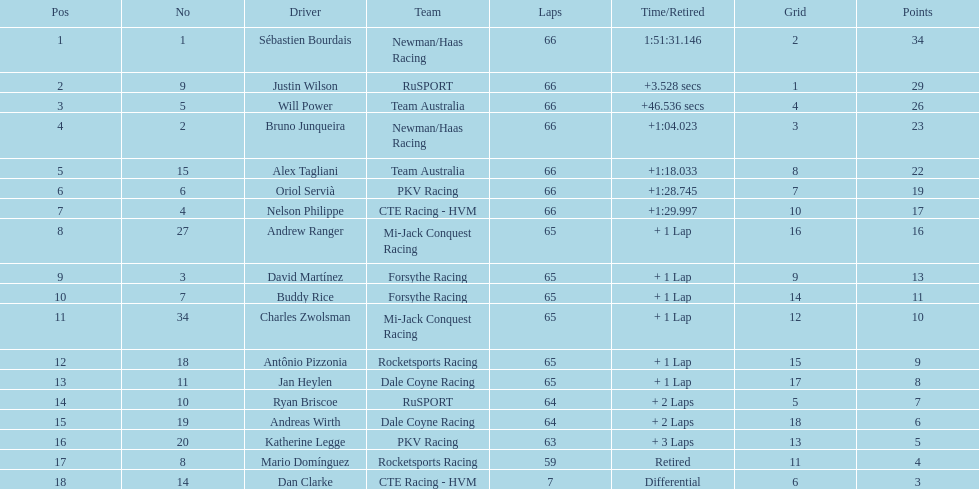Which driver possesses the same number as their ranking? Sébastien Bourdais. 